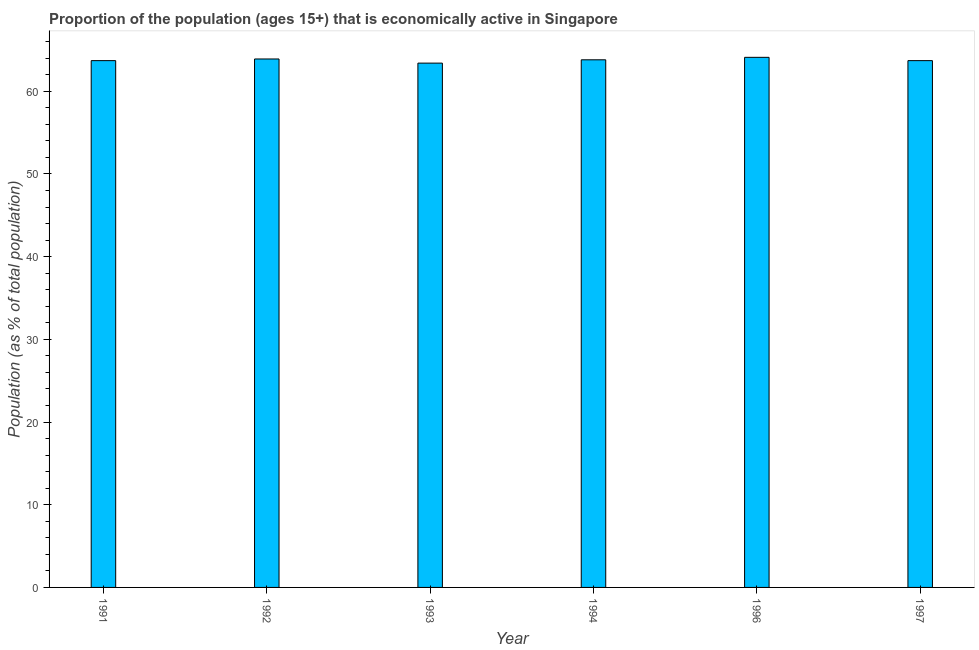Does the graph contain grids?
Ensure brevity in your answer.  No. What is the title of the graph?
Provide a short and direct response. Proportion of the population (ages 15+) that is economically active in Singapore. What is the label or title of the Y-axis?
Provide a short and direct response. Population (as % of total population). What is the percentage of economically active population in 1991?
Give a very brief answer. 63.7. Across all years, what is the maximum percentage of economically active population?
Your response must be concise. 64.1. Across all years, what is the minimum percentage of economically active population?
Ensure brevity in your answer.  63.4. In which year was the percentage of economically active population maximum?
Provide a short and direct response. 1996. What is the sum of the percentage of economically active population?
Provide a succinct answer. 382.6. What is the difference between the percentage of economically active population in 1996 and 1997?
Your response must be concise. 0.4. What is the average percentage of economically active population per year?
Give a very brief answer. 63.77. What is the median percentage of economically active population?
Your answer should be compact. 63.75. Do a majority of the years between 1992 and 1994 (inclusive) have percentage of economically active population greater than 16 %?
Your answer should be compact. Yes. Is the difference between the percentage of economically active population in 1991 and 1996 greater than the difference between any two years?
Offer a terse response. No. What is the difference between the highest and the second highest percentage of economically active population?
Offer a very short reply. 0.2. Is the sum of the percentage of economically active population in 1992 and 1994 greater than the maximum percentage of economically active population across all years?
Make the answer very short. Yes. What is the difference between the highest and the lowest percentage of economically active population?
Your answer should be compact. 0.7. In how many years, is the percentage of economically active population greater than the average percentage of economically active population taken over all years?
Your answer should be very brief. 3. How many bars are there?
Your answer should be very brief. 6. How many years are there in the graph?
Your answer should be compact. 6. Are the values on the major ticks of Y-axis written in scientific E-notation?
Offer a very short reply. No. What is the Population (as % of total population) in 1991?
Provide a succinct answer. 63.7. What is the Population (as % of total population) in 1992?
Your answer should be compact. 63.9. What is the Population (as % of total population) of 1993?
Ensure brevity in your answer.  63.4. What is the Population (as % of total population) of 1994?
Give a very brief answer. 63.8. What is the Population (as % of total population) of 1996?
Your response must be concise. 64.1. What is the Population (as % of total population) in 1997?
Your answer should be compact. 63.7. What is the difference between the Population (as % of total population) in 1991 and 1993?
Make the answer very short. 0.3. What is the difference between the Population (as % of total population) in 1991 and 1994?
Give a very brief answer. -0.1. What is the difference between the Population (as % of total population) in 1992 and 1994?
Offer a terse response. 0.1. What is the difference between the Population (as % of total population) in 1992 and 1996?
Provide a succinct answer. -0.2. What is the difference between the Population (as % of total population) in 1993 and 1996?
Offer a terse response. -0.7. What is the difference between the Population (as % of total population) in 1994 and 1996?
Offer a very short reply. -0.3. What is the ratio of the Population (as % of total population) in 1991 to that in 1994?
Provide a short and direct response. 1. What is the ratio of the Population (as % of total population) in 1991 to that in 1996?
Provide a succinct answer. 0.99. What is the ratio of the Population (as % of total population) in 1991 to that in 1997?
Make the answer very short. 1. What is the ratio of the Population (as % of total population) in 1992 to that in 1993?
Your response must be concise. 1.01. What is the ratio of the Population (as % of total population) in 1992 to that in 1996?
Ensure brevity in your answer.  1. What is the ratio of the Population (as % of total population) in 1993 to that in 1994?
Give a very brief answer. 0.99. What is the ratio of the Population (as % of total population) in 1993 to that in 1997?
Your response must be concise. 0.99. What is the ratio of the Population (as % of total population) in 1994 to that in 1997?
Ensure brevity in your answer.  1. 